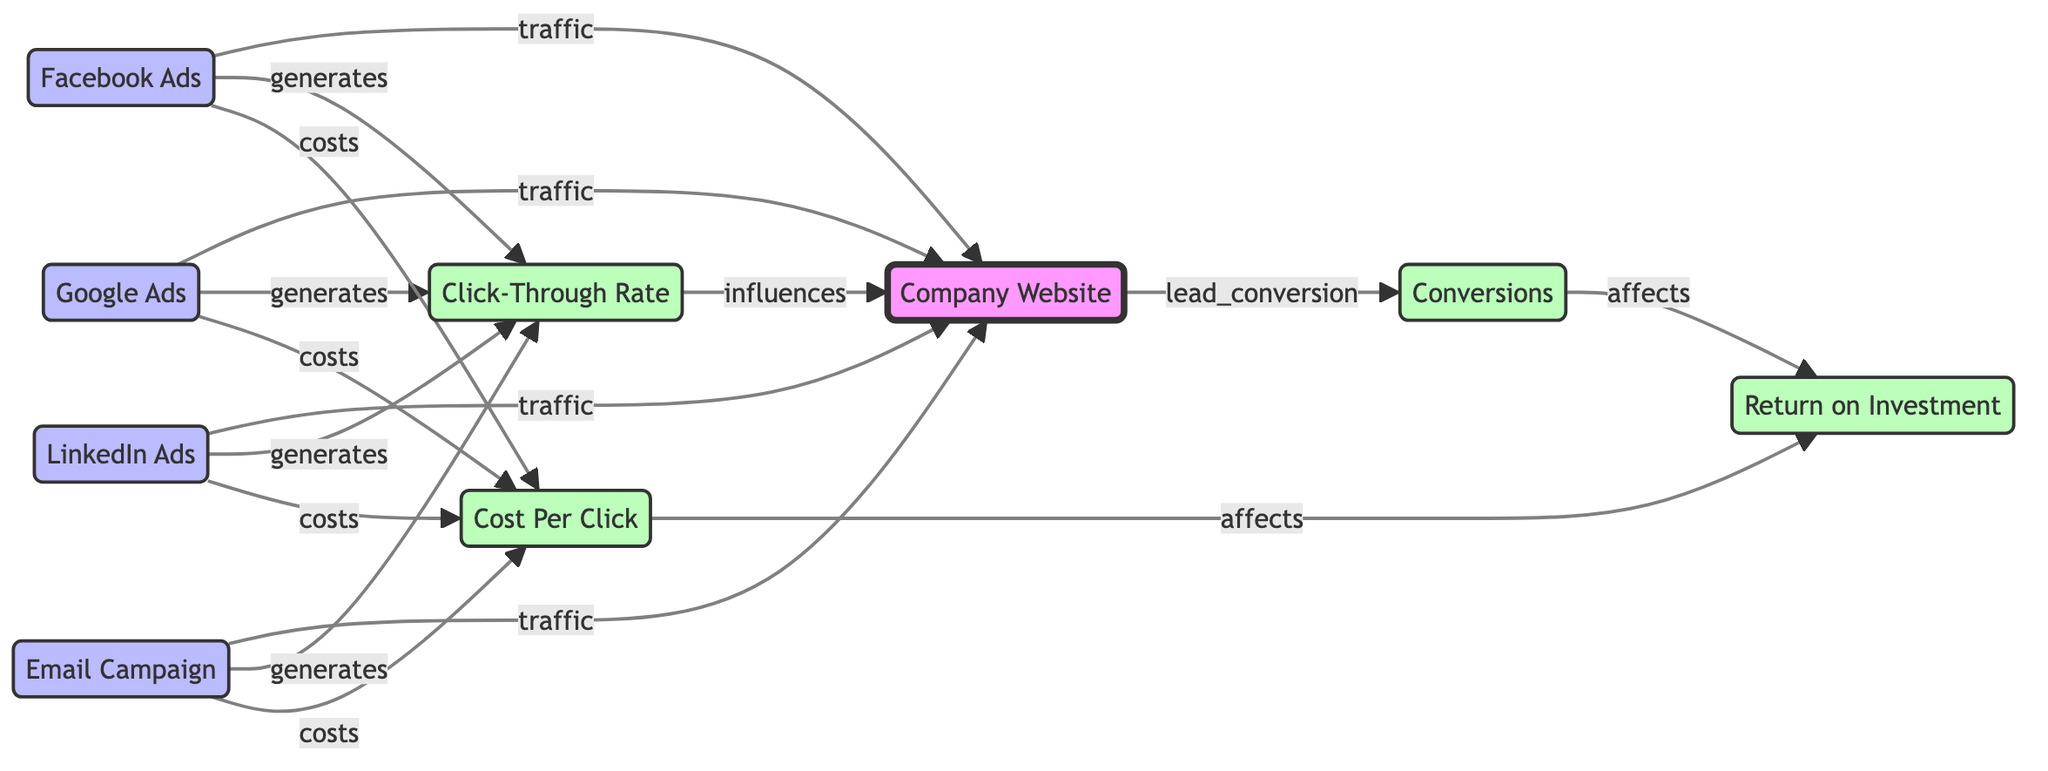What are the total number of nodes in the diagram? The diagram contains 8 nodes. This can be counted directly from the provided data under the "nodes" key.
Answer: 8 Which ad channel generates the most traffic to the company website? All four ad channels (Facebook Ads, Google Ads, Email Campaign, LinkedIn Ads) directly connect to the Company Website with a traffic label; no single ad channel is specified as generating the most by the labels.
Answer: All What affects the ROI according to the diagram? The diagram indicates that both Conversions and CPC influence or affect the ROI. This can be traced through the edges connecting these nodes to the ROI.
Answer: Conversions and CPC Which ad channels generate the Click-Through Rate (CTR)? Facebook Ads, Google Ads, Email Campaign, and LinkedIn Ads all generate CTR. This is confirmed by the edges labeled "generates" connecting these ad channels to CTR.
Answer: Facebook Ads, Google Ads, Email Campaign, LinkedIn Ads If the CPC is high, what is its potential effect on ROI? The diagram indicates that a higher CPC will lead to a reduction in ROI because CPC is connected to ROI and affects it negatively as indicated by the "affects" label.
Answer: Decrease How many edges are dedicated to traffic between ad channels and the company website? There are four edges labeled "traffic" connecting the ad channels (Facebook Ads, Google Ads, Email Campaign, LinkedIn Ads) to the Company Website.
Answer: 4 Which metric is influenced by the Click-Through Rate (CTR)? The Website is influenced by CTR, as shown by the edge labeled "influences" connecting CTR to the Company Website in the diagram.
Answer: Company Website What is the relationship between Conversions and ROI? The relationship is that Conversions directly affect ROI, indicated by the edge labeled "affects" connecting these two nodes.
Answer: Affects 